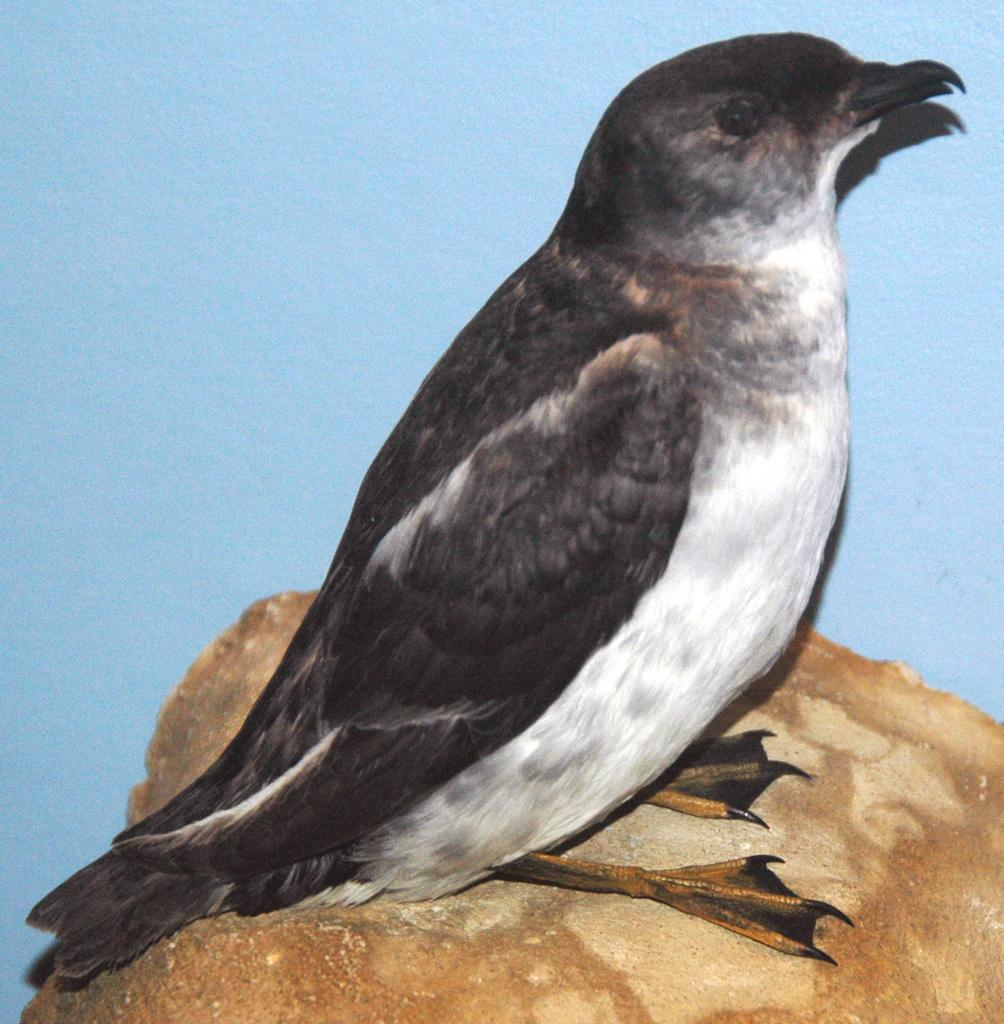What type of bird is in the image? There is a south georgia diving petrel in the image. What is the surface the bird is standing on? The south georgia diving petrel is on a brown surface. What color is the background of the image? The background of the image is blue. How many girls are playing with a stick in the snow in the image? There are no girls or snow present in the image; it features a south georgia diving petrel on a brown surface with a blue background. 